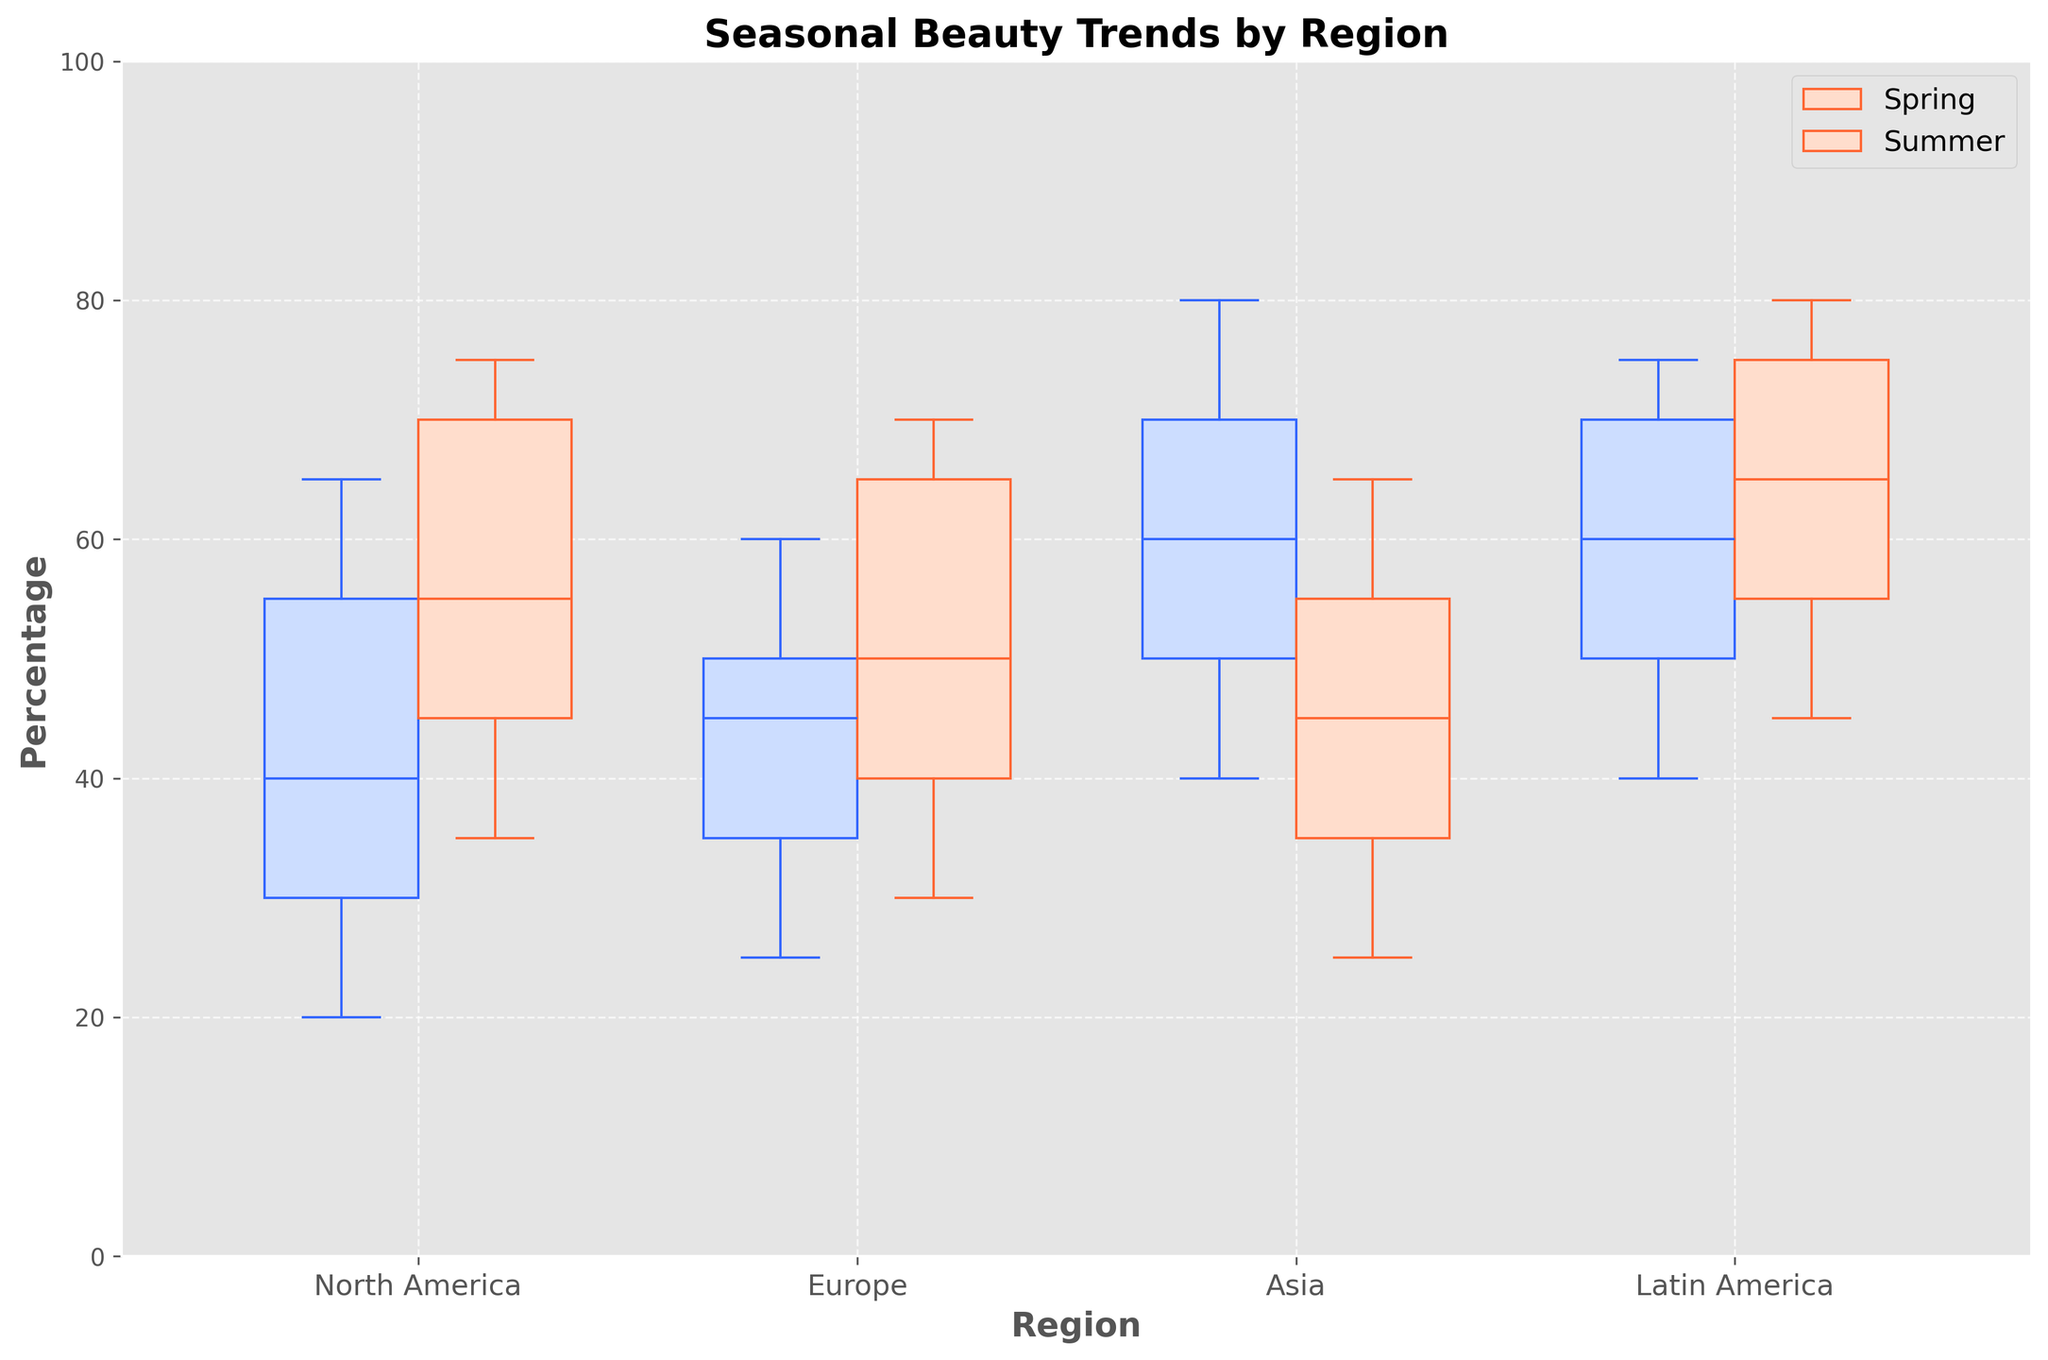What are the two seasons compared in the plot? The plot compares two seasons, which are indicated as different colored box plots. These seasons are labeled as 'Spring' and 'Summer' in the legend.
Answer: Spring and Summer How many regions are analyzed in the plot? The x-axis labels indicate the number of regions analyzed. The regions are 'North America,' 'Europe,' 'Asia,' and 'Latin America.'
Answer: 4 Which season has a higher median percentage for 'North America'? By observing the box plots for 'North America,' the median line inside the boxes indicates the central tendency. For 'North America,' the median line of 'Summer' (blue) box plot is higher than the one for 'Spring' (orange).
Answer: Summer What is the median percentage for 'Spring' in 'Europe'? By examining the horizontal line within the 'Spring' box plot for 'Europe,' the median percentage can be identified.
Answer: 50% Which season has a broader range of percentages for 'Asia'? To determine the range, look at the distance between the top and bottom whiskers of the 'Spring' and 'Summer' box plots for 'Asia.' 'Spring' (blue) shows a broader range.
Answer: Spring How do the median percentages for 'Spring' in 'Asia' and 'Spring' in 'Latin America' compare? Compare the medians of the 'Spring' box plots for 'Asia' (blue) and 'Latin America' (blue). The median for 'Spring' in 'Asia' is higher than in 'Latin America.'
Answer: Asia is higher Which region shows the smallest interquartile range (IQR) for 'Summer'? The IQR is the difference between the top and bottom edges of the box. The region with the smallest IQR for 'Summer' can be identified by measuring the height of the 'Summer' box plots. 'Latin America' has the smallest IQR.
Answer: Latin America What trend can be observed regarding age groups across all regions for 'Spring'? In the grouped box plots for 'Spring' across all regions, it is noticeable that the median percentages tend to decrease as the age groups increase. This trend indicates a lower popularity of certain beauty trends among older age groups.
Answer: Decreasing medians with increasing age groups Does any region have a higher overall median percentage in 'Summer' than any region in 'Spring'? To assess this, compare the highest median percentage for 'Summer' box plots and the highest median percentage for 'Spring' box plots across all regions. The highest median in 'Summer' exceeds the highest median in 'Spring.'
Answer: Yes What is the title of the plot? The title of the plot is displayed at the top and provides a concise description of the data being presented.
Answer: Seasonal Beauty Trends by Region 